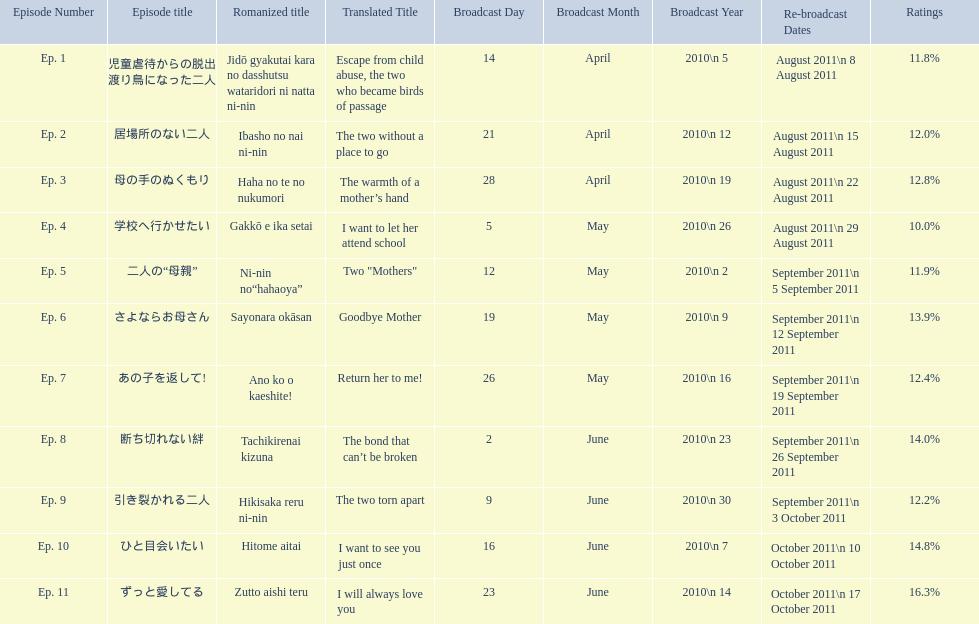What was the name of the next episode after goodbye mother? あの子を返して!. 